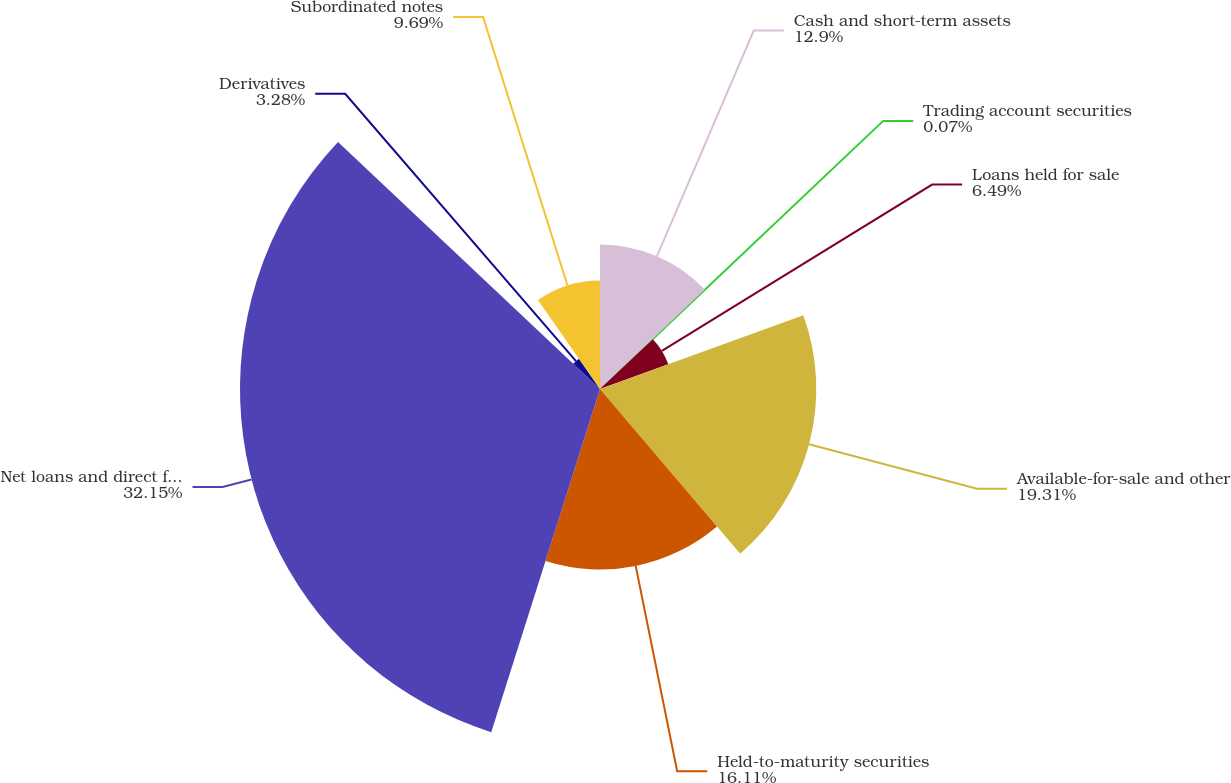<chart> <loc_0><loc_0><loc_500><loc_500><pie_chart><fcel>Cash and short-term assets<fcel>Trading account securities<fcel>Loans held for sale<fcel>Available-for-sale and other<fcel>Held-to-maturity securities<fcel>Net loans and direct financing<fcel>Derivatives<fcel>Subordinated notes<nl><fcel>12.9%<fcel>0.07%<fcel>6.49%<fcel>19.31%<fcel>16.11%<fcel>32.14%<fcel>3.28%<fcel>9.69%<nl></chart> 